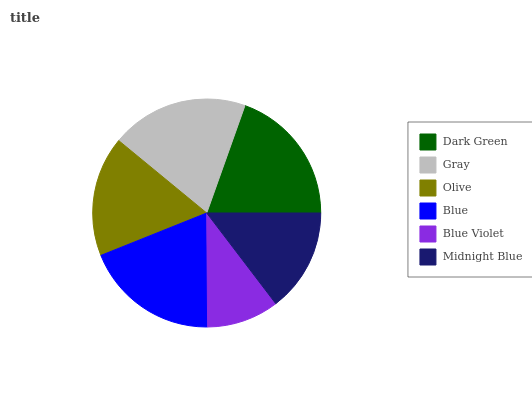Is Blue Violet the minimum?
Answer yes or no. Yes. Is Dark Green the maximum?
Answer yes or no. Yes. Is Gray the minimum?
Answer yes or no. No. Is Gray the maximum?
Answer yes or no. No. Is Dark Green greater than Gray?
Answer yes or no. Yes. Is Gray less than Dark Green?
Answer yes or no. Yes. Is Gray greater than Dark Green?
Answer yes or no. No. Is Dark Green less than Gray?
Answer yes or no. No. Is Blue the high median?
Answer yes or no. Yes. Is Olive the low median?
Answer yes or no. Yes. Is Dark Green the high median?
Answer yes or no. No. Is Midnight Blue the low median?
Answer yes or no. No. 